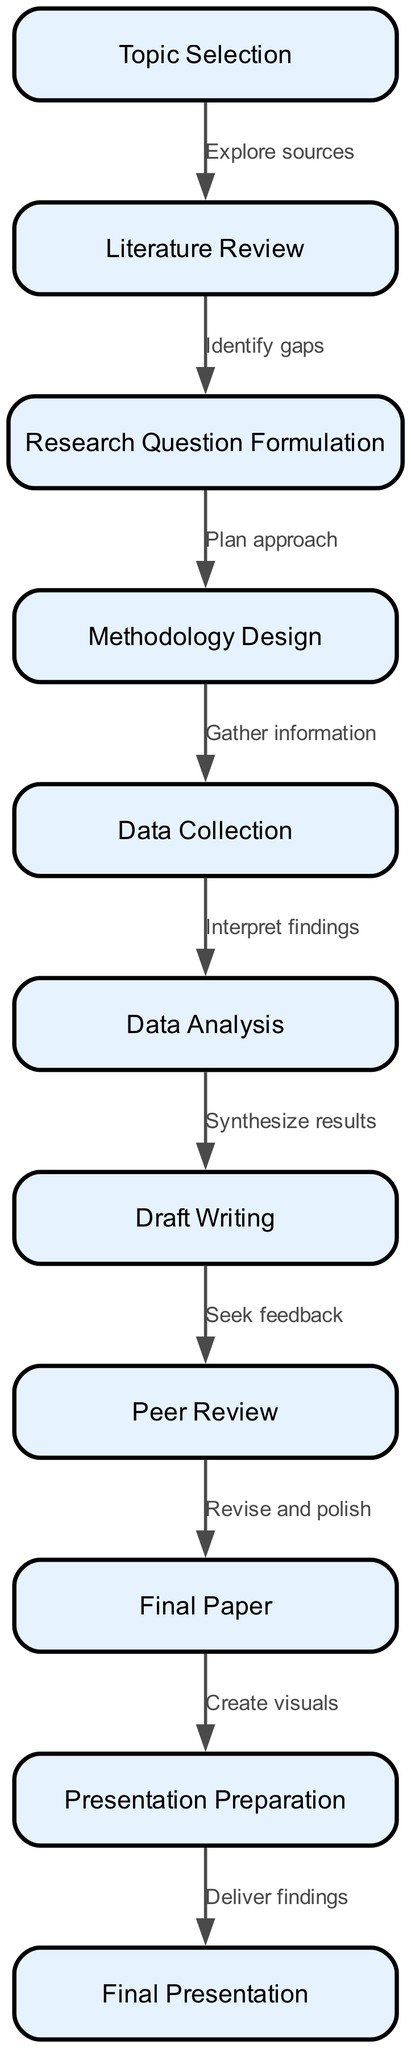What is the first stage of the research project? The first node in the flowchart is "Topic Selection." This is indicated directly as the starting point of the flowchart, showing that this is where the research process begins.
Answer: Topic Selection How many total stages are depicted in the diagram? By counting the nodes, there are eleven distinct stages listed within the flowchart that represent the various steps in a high school research project.
Answer: Eleven What relationship is established between "Literature Review" and "Research Question Formulation"? The edge connecting these two nodes indicates that after conducting a literature review, the next step is to "Identify gaps," which directly leads to "Research Question Formulation." This shows the progression from reviewing existing literature to formulating new research questions.
Answer: Identify gaps What stage follows "Draft Writing"? The flowchart indicates that after "Draft Writing," the subsequent stage is "Peer Review." This can be directly observed through the directed edge leading to the next node in the sequence.
Answer: Peer Review Which stage involves the creation of visuals? The node "Presentation Preparation" specifically mentions "Create visuals" as the relevant activity to be conducted in preparation for the final presentation, highlighting the importance of visual aids in effective communication.
Answer: Create visuals What is the final output of the research process? The last node in the flowchart is "Final Presentation," which represents the culmination of all previous stages, demonstrating that the ultimate goal of the research project is to present the findings.
Answer: Final Presentation What two stages occur before "Data Analysis"? The stages preceding "Data Analysis" are "Data Collection" and "Methodology Design." This sequence must be followed as the research progresses from designing a methodology to the actual collection of data before moving on to analysis.
Answer: Methodology Design and Data Collection How is "Final Paper" related to "Peer Review"? The edge between these two nodes illustrates that, after the "Peer Review" phase, the researcher revises and polishes their findings to produce the "Final Paper," showcasing the iterative nature of research writing.
Answer: Revise and polish 